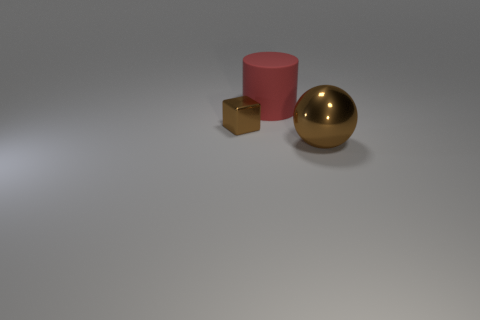Is there a tiny metal block of the same color as the big ball?
Offer a very short reply. Yes. There is a thing right of the big red matte thing; does it have the same size as the object that is behind the small brown metallic block?
Your response must be concise. Yes. Is the number of large matte cylinders to the left of the big brown thing greater than the number of tiny brown cubes on the right side of the large red matte cylinder?
Ensure brevity in your answer.  Yes. Is there a big object that has the same material as the brown cube?
Your response must be concise. Yes. Do the large metallic ball and the block have the same color?
Offer a very short reply. Yes. What material is the object that is both to the right of the block and to the left of the brown metal ball?
Your answer should be compact. Rubber. The big ball has what color?
Keep it short and to the point. Brown. What number of small brown metal things have the same shape as the red object?
Your answer should be very brief. 0. Do the object that is on the right side of the big red matte object and the big red cylinder to the left of the big brown shiny object have the same material?
Your answer should be very brief. No. What size is the red matte object on the left side of the shiny thing that is to the right of the small brown cube?
Your answer should be compact. Large. 